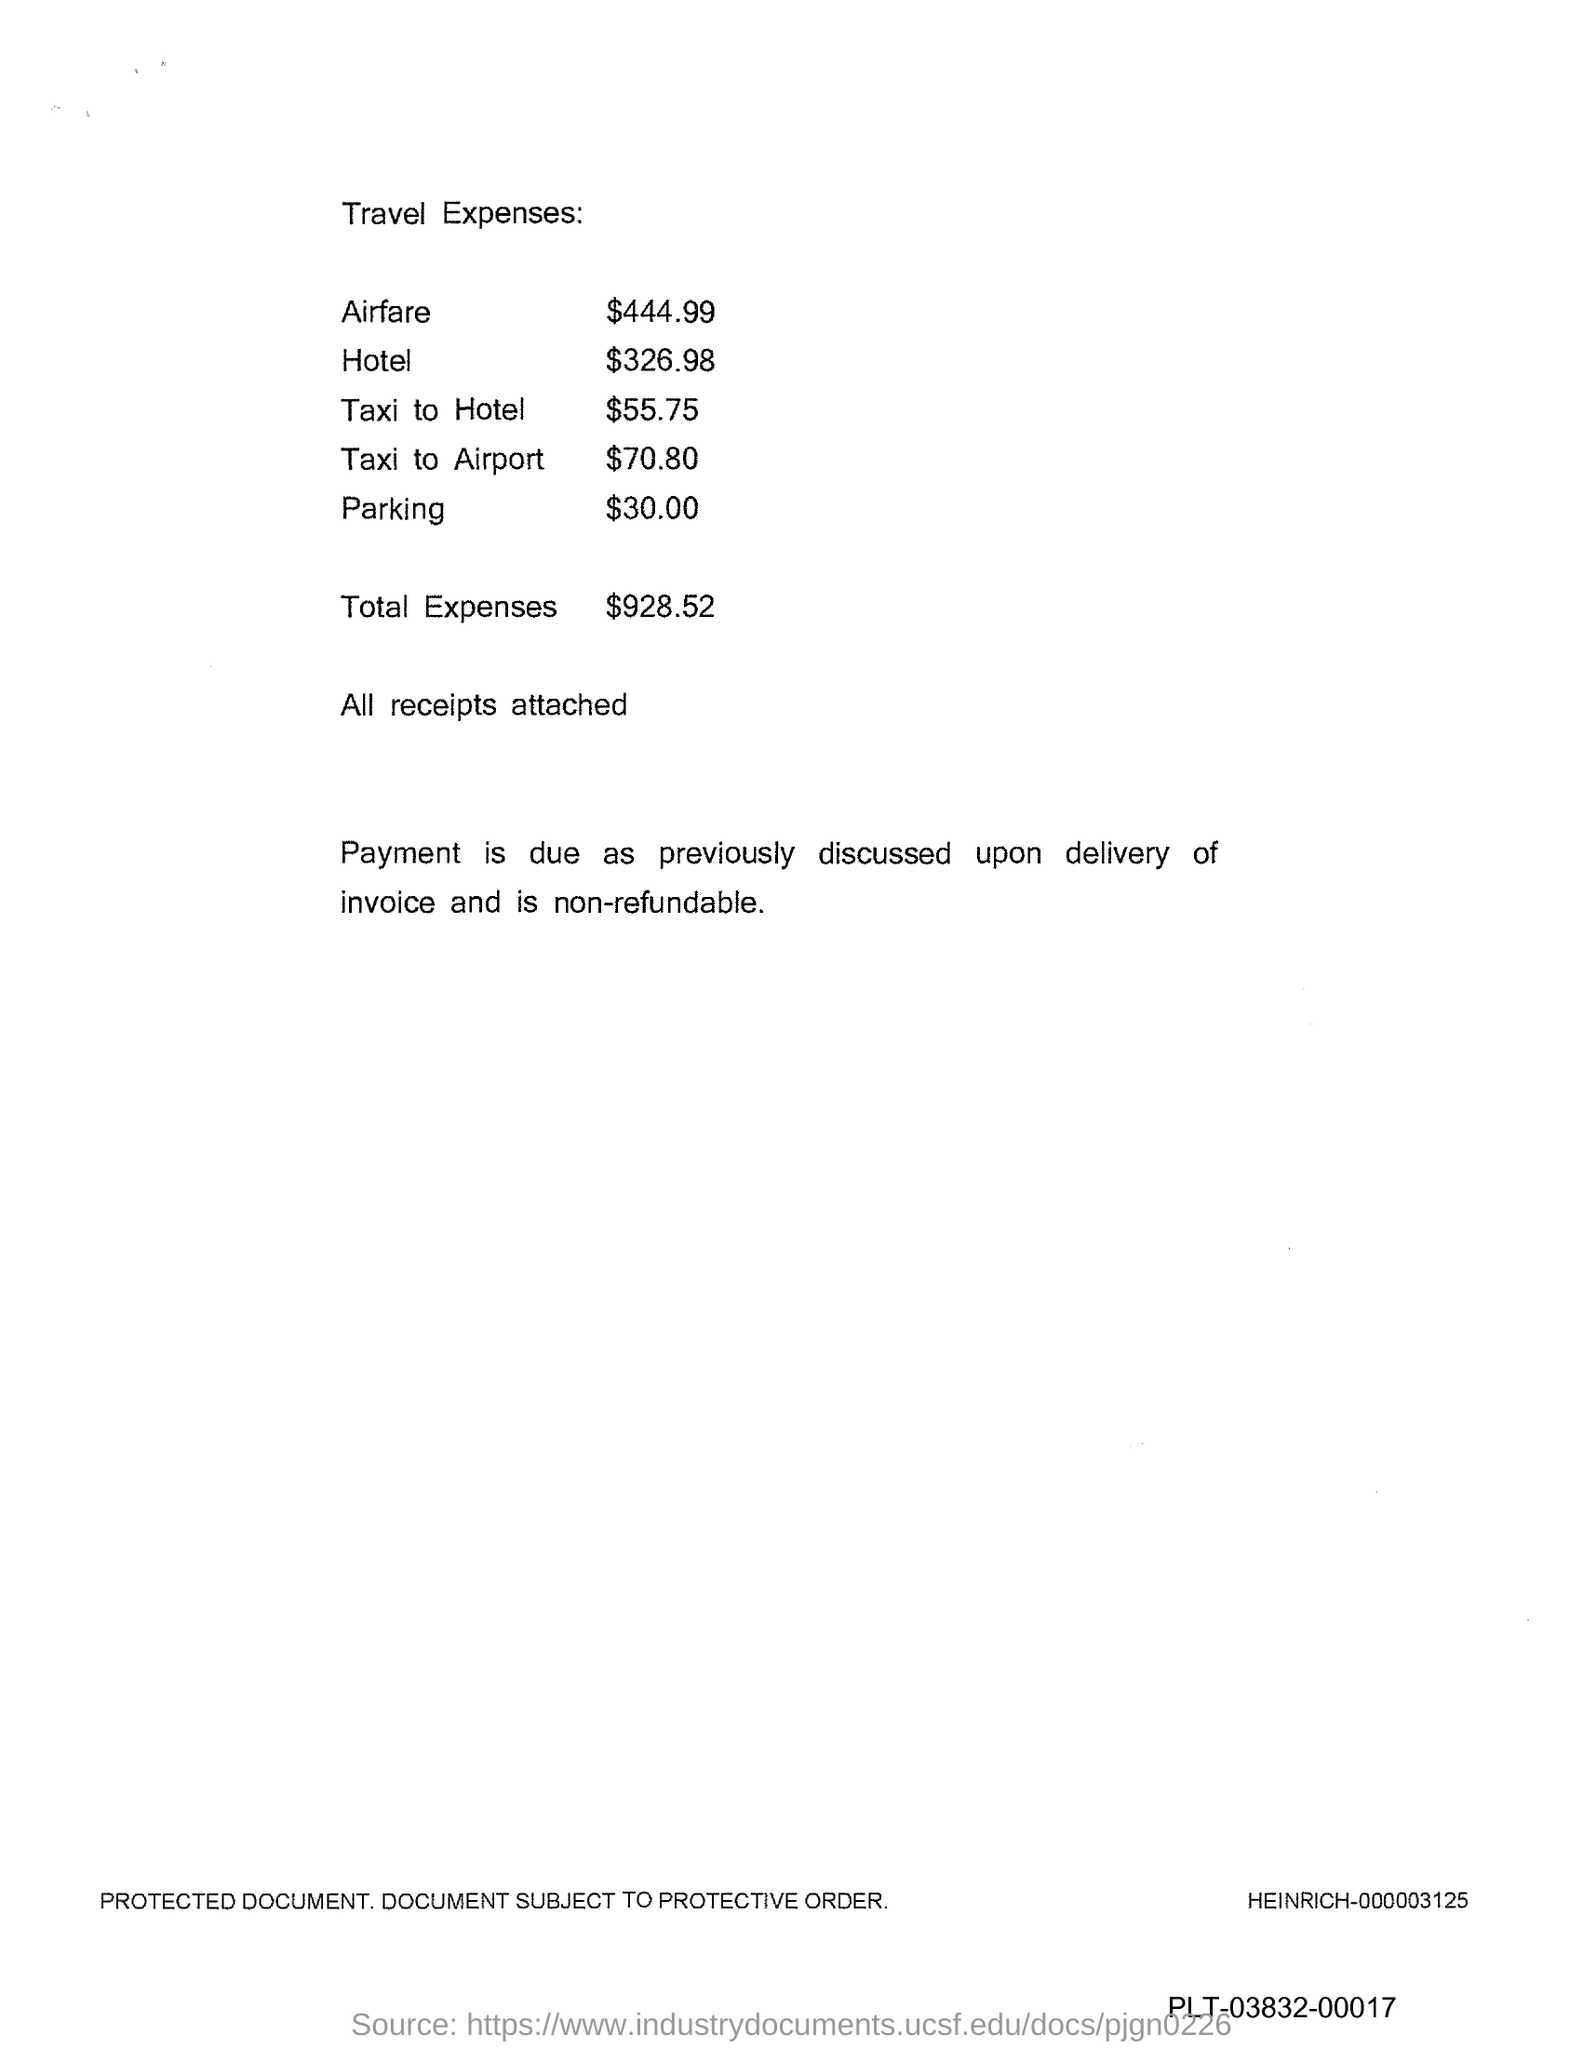What is the total expenses mentioned in the document?
Make the answer very short. $928.52. What is the hotel expense?
Your answer should be very brief. 326.98. What is the parking expense?
Your response must be concise. 30.00. 